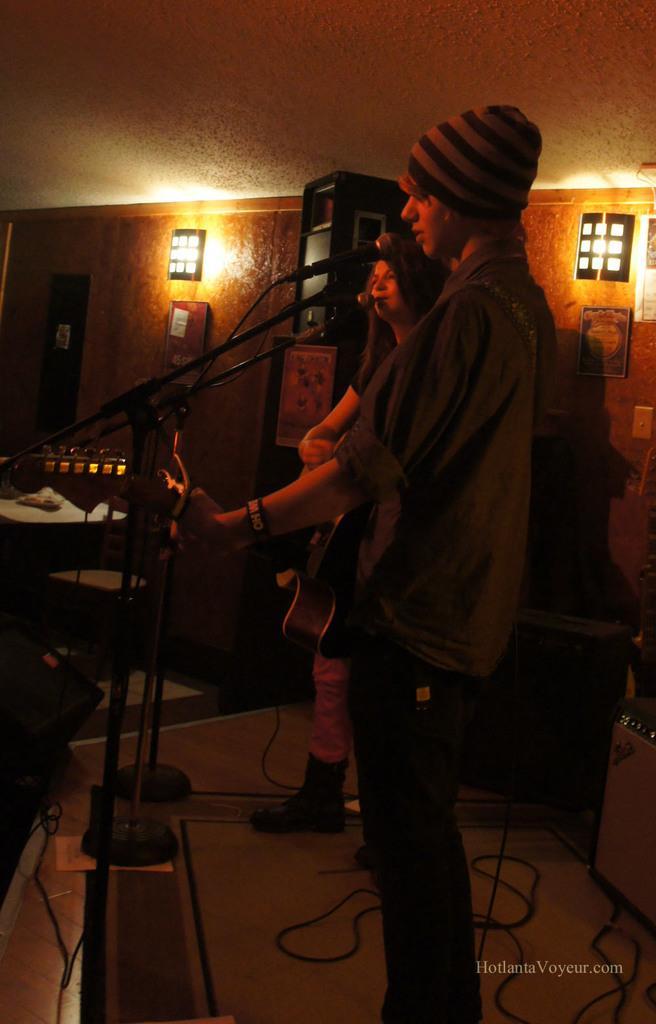Please provide a concise description of this image. In this image we can see a man wearing the cap and standing. We can also see the woman standing on the floor. We can also see the miles with the stands. Image also consists of a guitar, a table, paper, wires and also the frames attached to the wall. We can also see the lights, some objects and also the ceiling. In the bottom right corner we can see the text. 